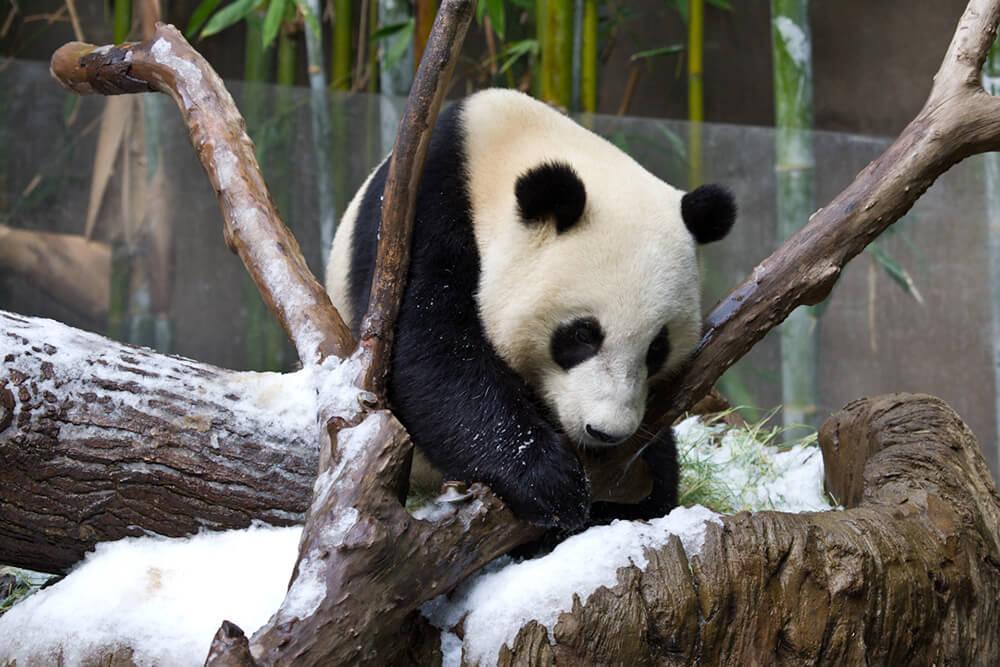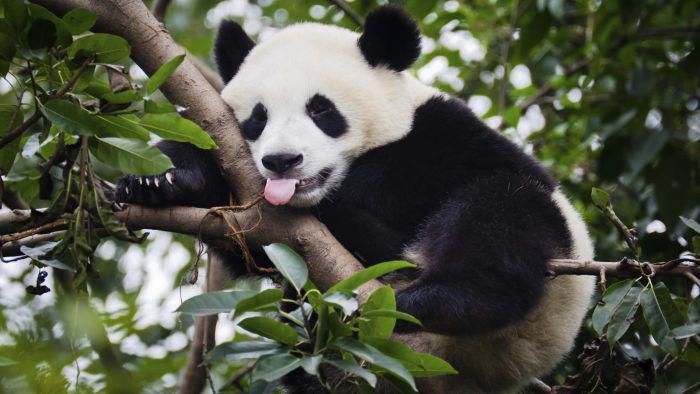The first image is the image on the left, the second image is the image on the right. Analyze the images presented: Is the assertion "There is at least one giant panda sitting in the grass and eating bamboo." valid? Answer yes or no. No. The first image is the image on the left, the second image is the image on the right. Assess this claim about the two images: "At least one panda is eating.". Correct or not? Answer yes or no. No. 